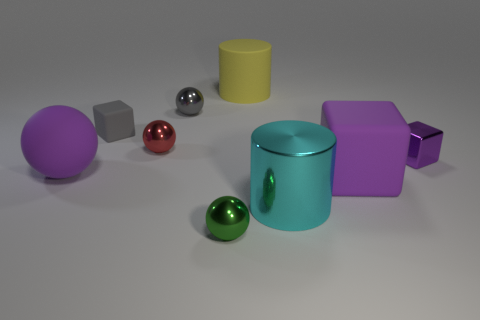Subtract 1 cubes. How many cubes are left? 2 Subtract all purple cubes. How many cubes are left? 1 Subtract all gray balls. How many balls are left? 3 Subtract all green blocks. Subtract all cyan cylinders. How many blocks are left? 3 Subtract all cylinders. How many objects are left? 7 Add 8 big cyan cylinders. How many big cyan cylinders exist? 9 Subtract 1 yellow cylinders. How many objects are left? 8 Subtract all tiny green metal balls. Subtract all small green metal balls. How many objects are left? 7 Add 8 big purple cubes. How many big purple cubes are left? 9 